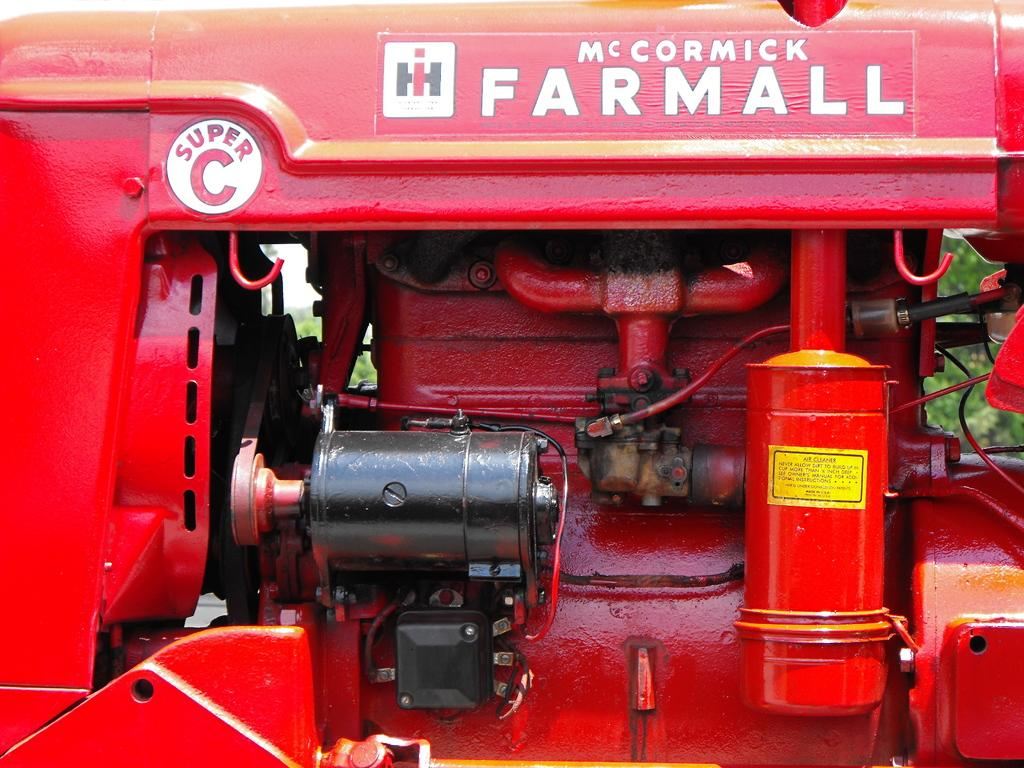What type of object is depicted in the image? There are parts of a vehicle in the image. Can you describe any specific details about the vehicle? There is text on the vehicle. What can be seen in the background of the image? There are trees in the background of the image. What type of slip is the partner wearing in the image? There is no partner or slip present in the image; it features parts of a vehicle with text and trees in the background. 